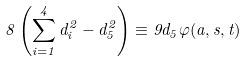Convert formula to latex. <formula><loc_0><loc_0><loc_500><loc_500>8 \left ( \sum _ { i = 1 } ^ { 4 } d _ { i } ^ { 2 } - d _ { 5 } ^ { 2 } \right ) \equiv 9 d _ { 5 } \varphi ( a , s , t )</formula> 